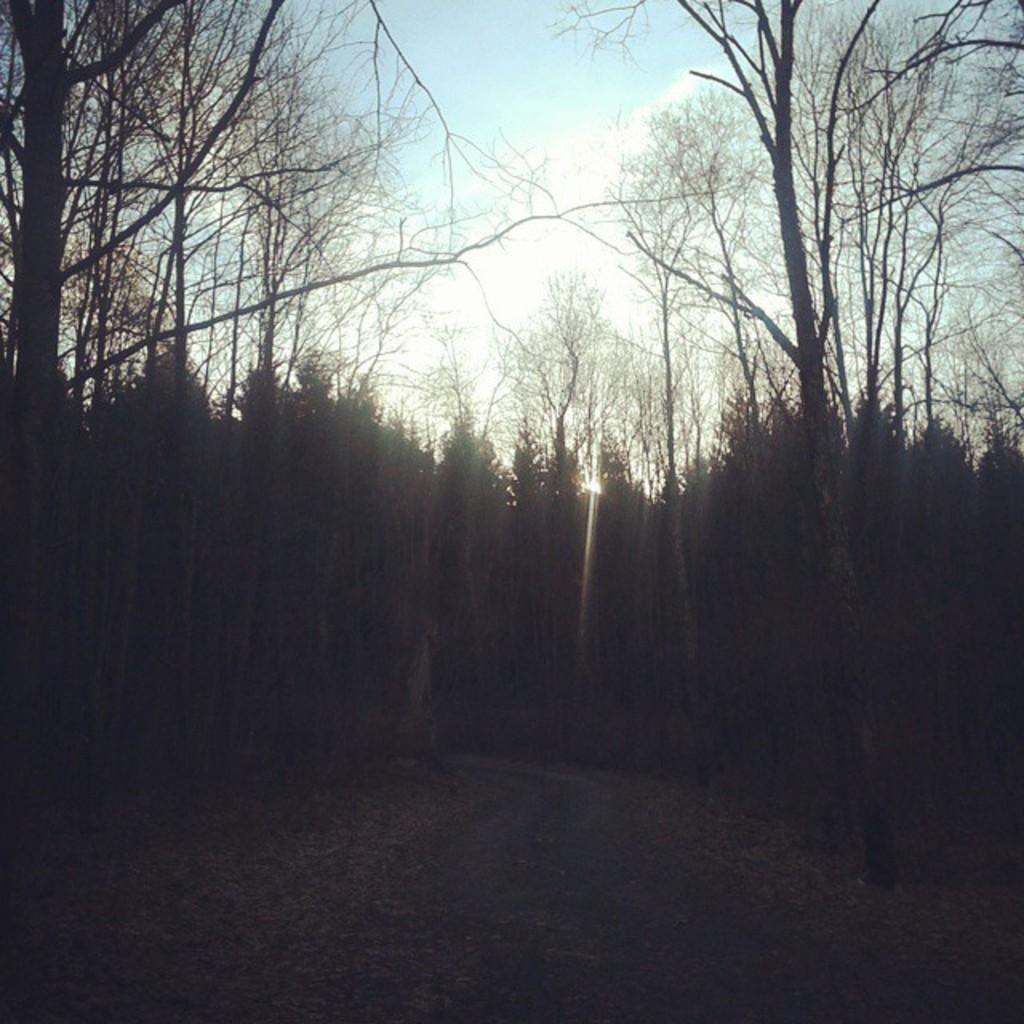What type of vegetation can be seen in the image? There are trees in the image. What part of the natural environment is visible in the image? The sky is visible in the image. How would you describe the color of the sky in the image? The sky has a combination of white and blue colors in the image. How would you describe the overall lighting in the image? The image appears to be a bit dark. What type of butter is being used to clean the dirt off the trees in the image? There is no butter or dirt present in the image; it only features trees and the sky. 